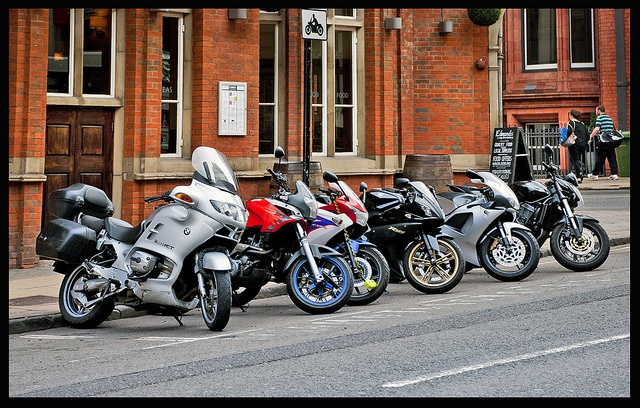Describe the objects in this image and their specific colors. I can see motorcycle in black, lightgray, darkgray, and gray tones, motorcycle in black, gray, lightgray, and darkgray tones, motorcycle in black, gray, lightgray, and darkgray tones, motorcycle in black, lightgray, darkgray, and gray tones, and motorcycle in black, gray, lightgray, and darkgray tones in this image. 